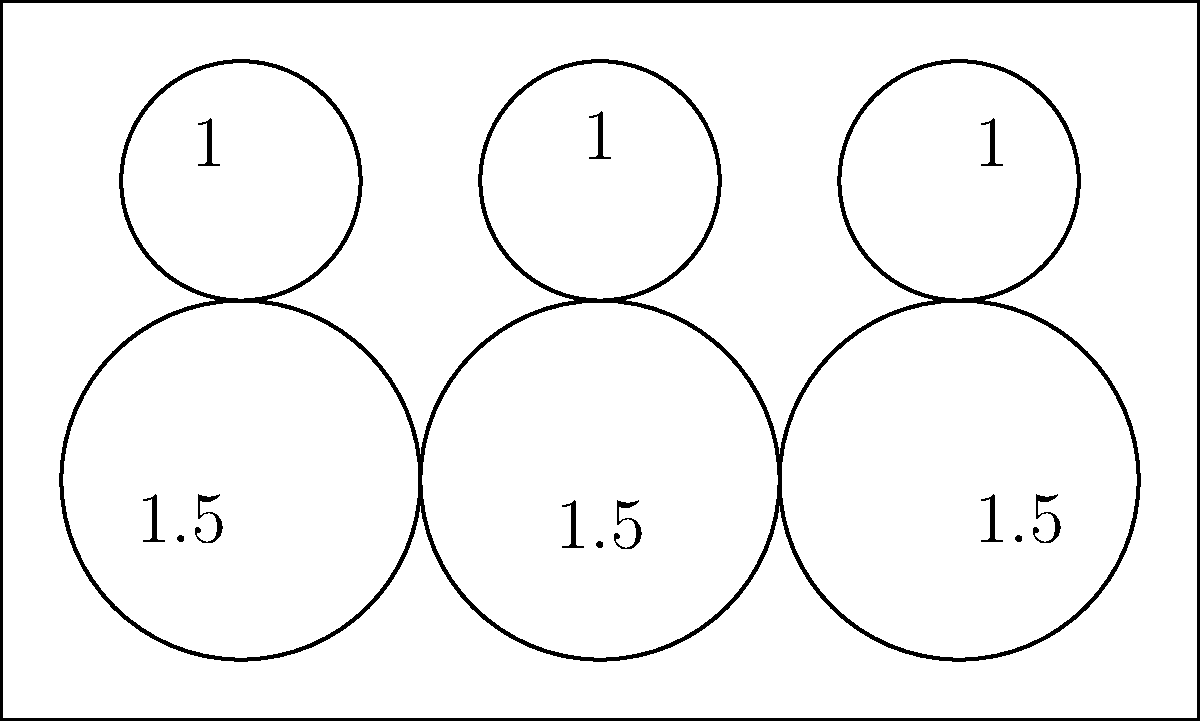In the context of optimizing texture atlases for game development, consider the circle packing arrangement shown in the rectangular boundary. What is the packing efficiency (ratio of total circle area to rectangle area) of this configuration, rounded to two decimal places? To calculate the packing efficiency, we need to follow these steps:

1. Calculate the area of the rectangle:
   $A_{rect} = 10 * 6 = 60$ square units

2. Calculate the total area of the circles:
   - Three circles with radius 1.5: $A_1 = 3 * \pi * 1.5^2 = 3 * \pi * 2.25 = 6.75\pi$
   - Three circles with radius 1: $A_2 = 3 * \pi * 1^2 = 3\pi$
   - Total circle area: $A_{total} = A_1 + A_2 = 6.75\pi + 3\pi = 9.75\pi$

3. Calculate the packing efficiency:
   $\text{Efficiency} = \frac{A_{total}}{A_{rect}} = \frac{9.75\pi}{60} \approx 0.5105$

4. Round to two decimal places:
   $0.5105 \approx 0.51$

Therefore, the packing efficiency is approximately 0.51 or 51%.
Answer: 0.51 